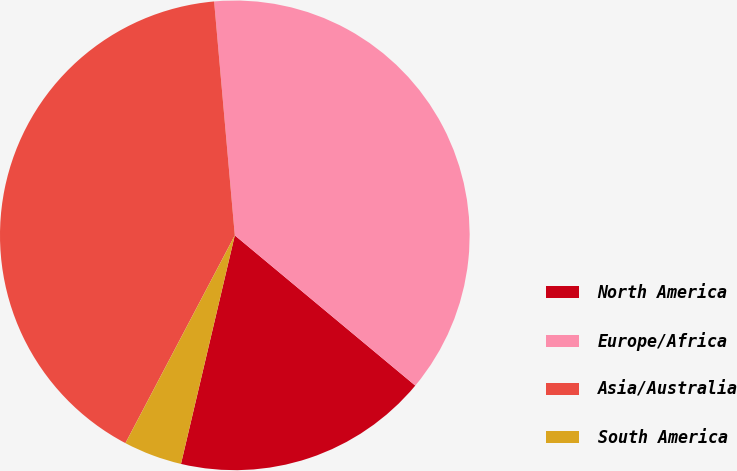Convert chart. <chart><loc_0><loc_0><loc_500><loc_500><pie_chart><fcel>North America<fcel>Europe/Africa<fcel>Asia/Australia<fcel>South America<nl><fcel>17.63%<fcel>37.45%<fcel>40.88%<fcel>4.03%<nl></chart> 